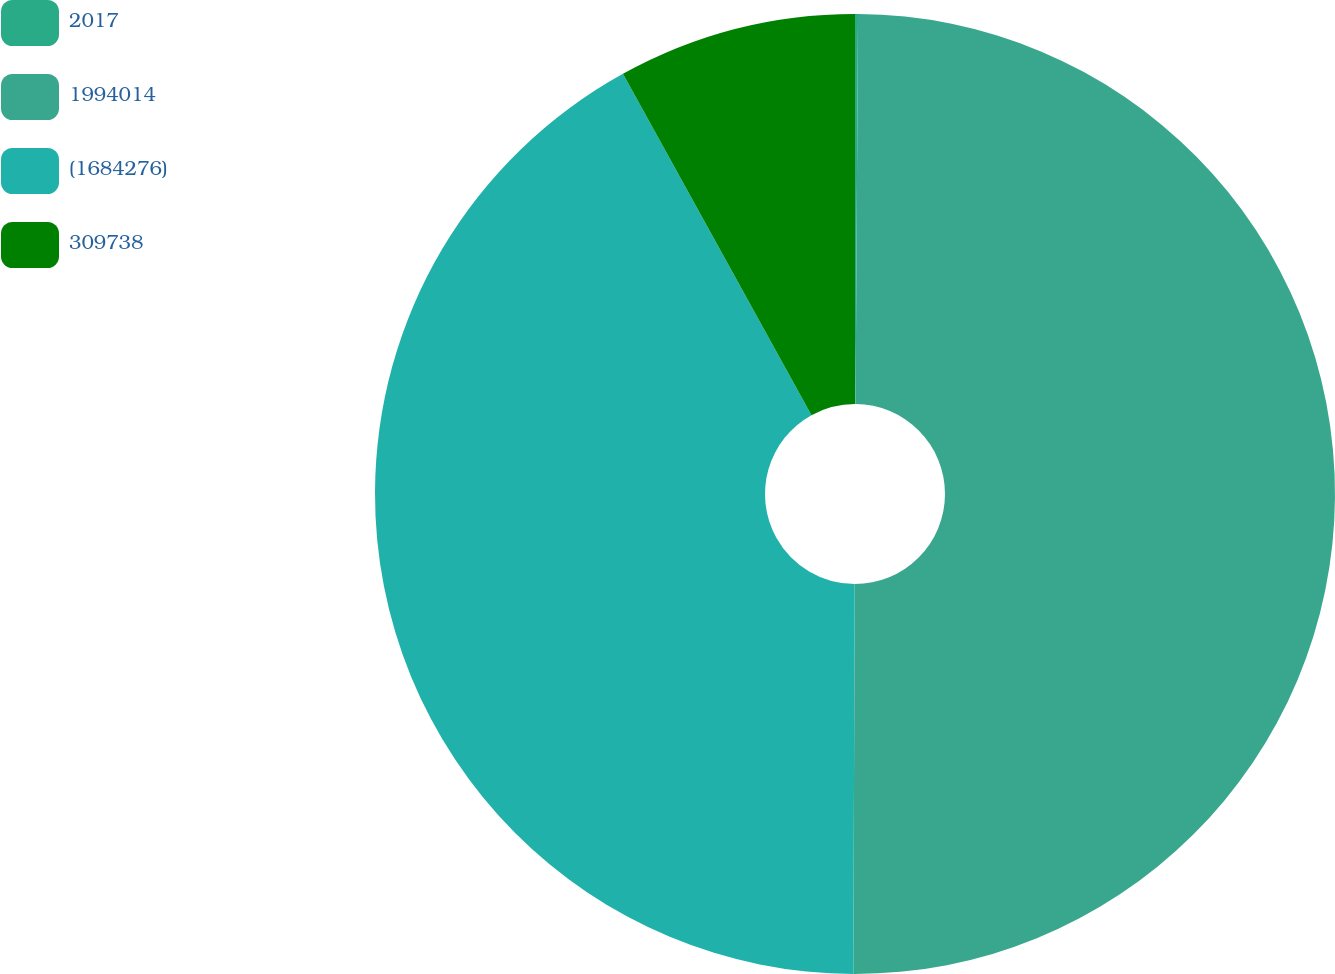Convert chart to OTSL. <chart><loc_0><loc_0><loc_500><loc_500><pie_chart><fcel>2017<fcel>1994014<fcel>(1684276)<fcel>309738<nl><fcel>0.1%<fcel>49.95%<fcel>41.91%<fcel>8.03%<nl></chart> 